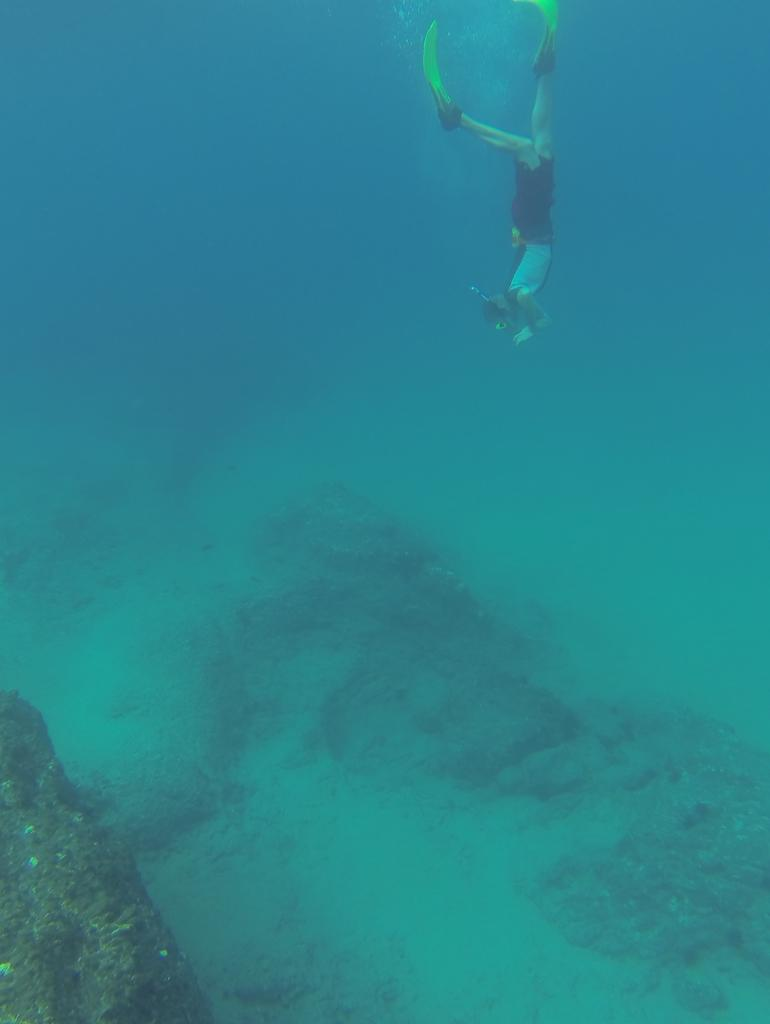What is the person in the image doing? The person is diving in water. What protective gear is the person wearing? The person is wearing goggles. What can be seen at the bottom of the image? There is land visible at the bottom of the image, and it has rocks on it. What is visible in the background of the image? There is water visible in the background of the image. What type of tail does the person have in the image? The person does not have a tail in the image; they are a human diver. 